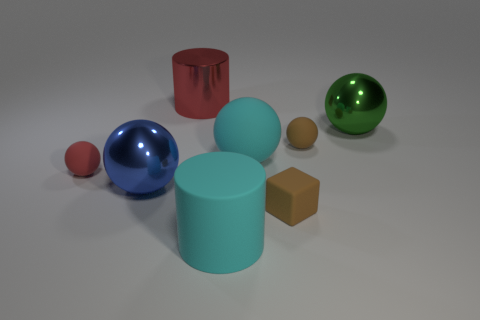Add 1 large blue things. How many objects exist? 9 Subtract all cubes. How many objects are left? 7 Subtract 1 brown blocks. How many objects are left? 7 Subtract all big gray metal spheres. Subtract all large metallic spheres. How many objects are left? 6 Add 6 large matte spheres. How many large matte spheres are left? 7 Add 4 gray metallic things. How many gray metallic things exist? 4 